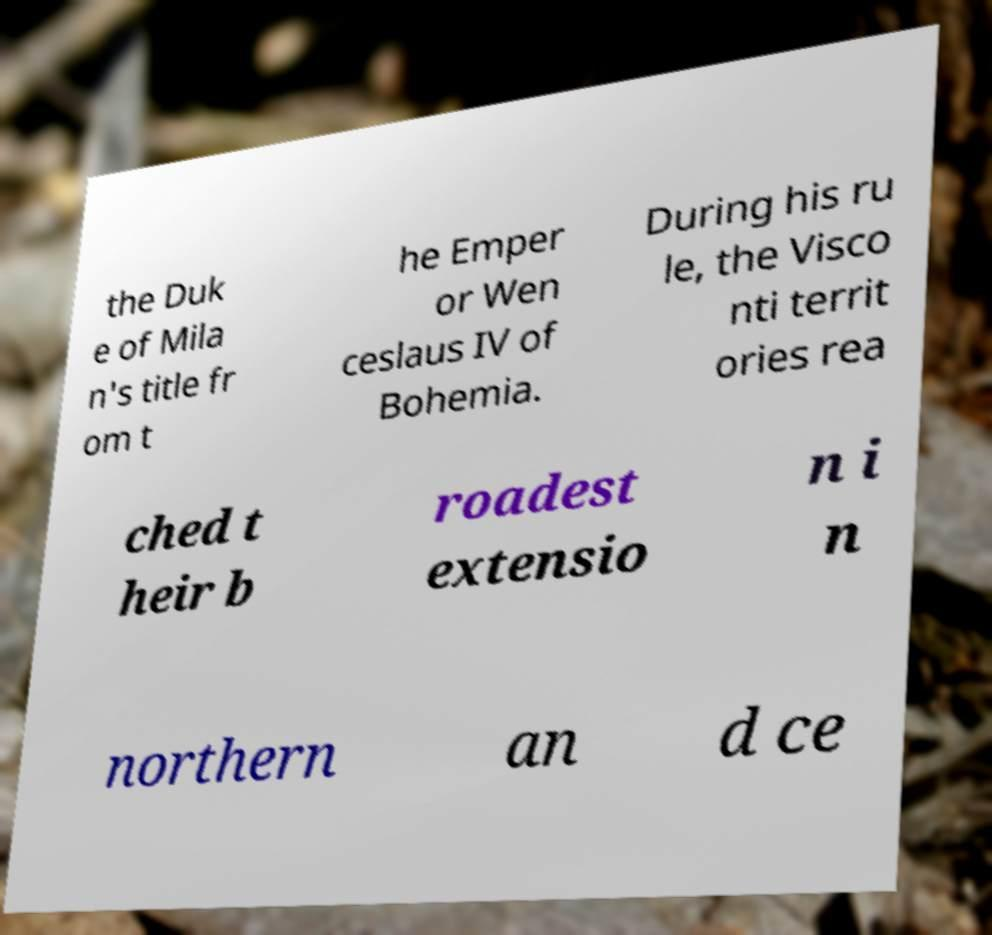For documentation purposes, I need the text within this image transcribed. Could you provide that? the Duk e of Mila n's title fr om t he Emper or Wen ceslaus IV of Bohemia. During his ru le, the Visco nti territ ories rea ched t heir b roadest extensio n i n northern an d ce 